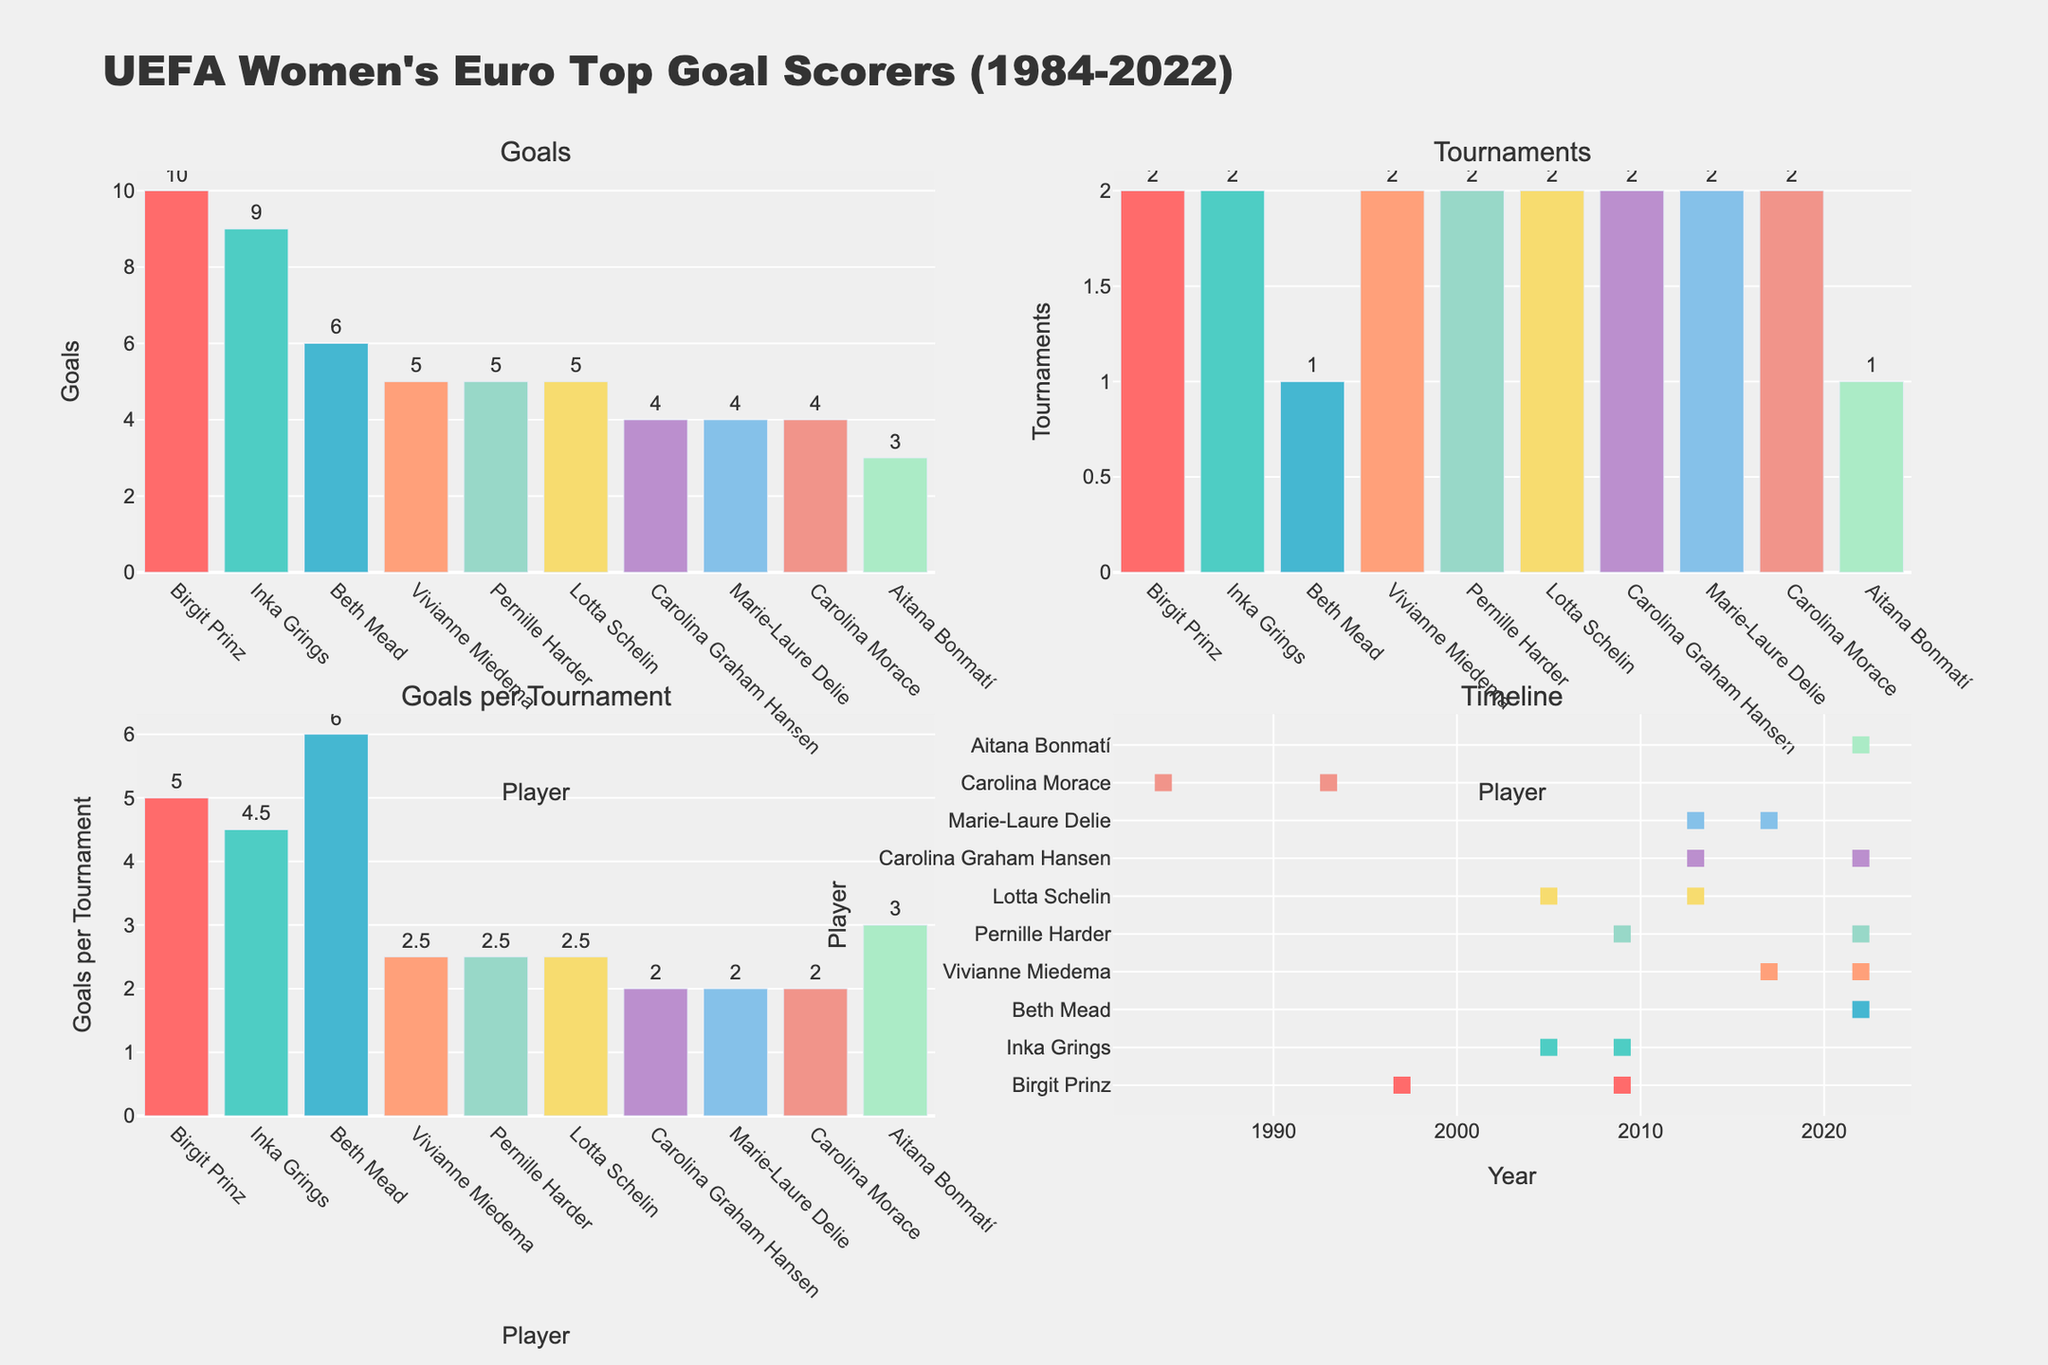What is the title of the figure? The title of the figure is stated at the top center in bold and large font.
Answer: SuplexMasterJay's Wrestling Merchandise Breakdown Which product category has the highest sales for WWE? Looking at the sub-plot for WWE, the tallest bar represents the highest sales.
Answer: T-Shirts How many categories of merchandise are shown in each sub-plot? Each sub-plot displays bars for merchandise categories like T-Shirts, Action Figures, Championship Belts, Posters, and Accessories. Count these categories.
Answer: 5 Which brand has the highest sale of Posters? Compare the height of the Poster bars in each subplot to find the tallest one.
Answer: ROH What is the total merchandise sales for AEW? Sum up the values of all the bars in the AEW subplot. (30 + 20 + 10 + 15 + 25)
Answer: 100 How do sales of Championship Belts in NJPW compare to those in Impact Wrestling? Look at the height of the bars for Championship Belts in NJPW and Impact Wrestling and compare their values.
Answer: NJPW has higher sales than Impact Wrestling Which brand has the most evenly distributed sales across all merchandise categories? Observe the subplots and find the brand where the bars are closest in height to each other across categories.
Answer: AEW What is the average sales count for the Accessories category across all brands? Sum the Accessories bars across all brands and divide by the number of brands (15 + 25 + 15 + 10 + 20) / 5.
Answer: 17 Which brand has the lowest sales in Action Figures, and what is that value? Compare the Action Figures bars in each subplot and find the lowest one.
Answer: NJPW, 15 How many brands have their highest sales in the T-Shirts category? Count the subplots where the T-Shirts bar is the tallest bar within that subplot.
Answer: 3 